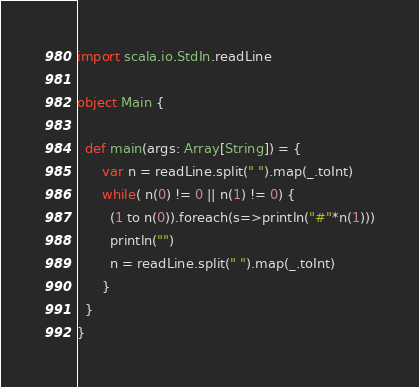<code> <loc_0><loc_0><loc_500><loc_500><_Scala_>import scala.io.StdIn.readLine

object Main {

  def main(args: Array[String]) = {
      var n = readLine.split(" ").map(_.toInt)
      while( n(0) != 0 || n(1) != 0) {
        (1 to n(0)).foreach(s=>println("#"*n(1)))
        println("")
        n = readLine.split(" ").map(_.toInt)
      }
  }
}</code> 